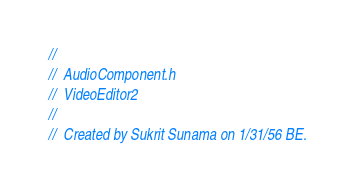<code> <loc_0><loc_0><loc_500><loc_500><_C_>//
//  AudioComponent.h
//  VideoEditor2
//
//  Created by Sukrit Sunama on 1/31/56 BE.</code> 